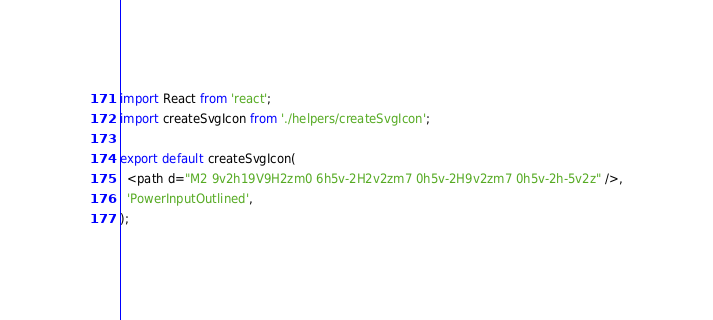<code> <loc_0><loc_0><loc_500><loc_500><_TypeScript_>import React from 'react';
import createSvgIcon from './helpers/createSvgIcon';

export default createSvgIcon(
  <path d="M2 9v2h19V9H2zm0 6h5v-2H2v2zm7 0h5v-2H9v2zm7 0h5v-2h-5v2z" />,
  'PowerInputOutlined',
);
</code> 